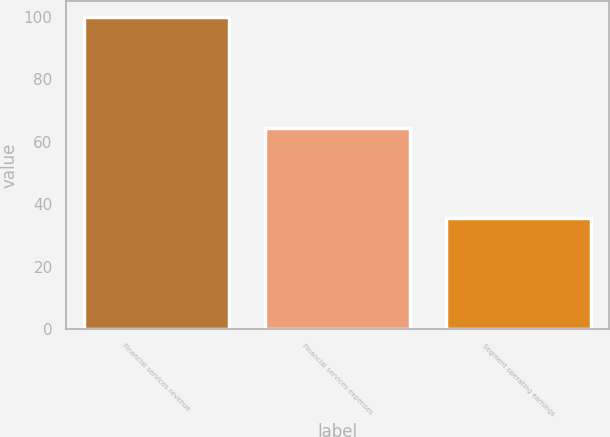<chart> <loc_0><loc_0><loc_500><loc_500><bar_chart><fcel>Financial services revenue<fcel>Financial services expenses<fcel>Segment operating earnings<nl><fcel>100<fcel>64.4<fcel>35.6<nl></chart> 